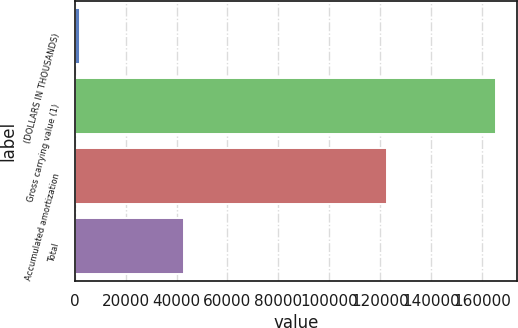Convert chart to OTSL. <chart><loc_0><loc_0><loc_500><loc_500><bar_chart><fcel>(DOLLARS IN THOUSANDS)<fcel>Gross carrying value (1)<fcel>Accumulated amortization<fcel>Total<nl><fcel>2011<fcel>165406<fcel>122643<fcel>42763<nl></chart> 